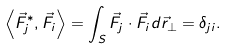<formula> <loc_0><loc_0><loc_500><loc_500>\left < \vec { F } _ { j } ^ { * } , { \vec { F } } _ { i } \right > = \int _ { S } \vec { F } _ { j } \cdot \vec { F } _ { i } d \vec { r } _ { \bot } = \delta _ { j i } .</formula> 